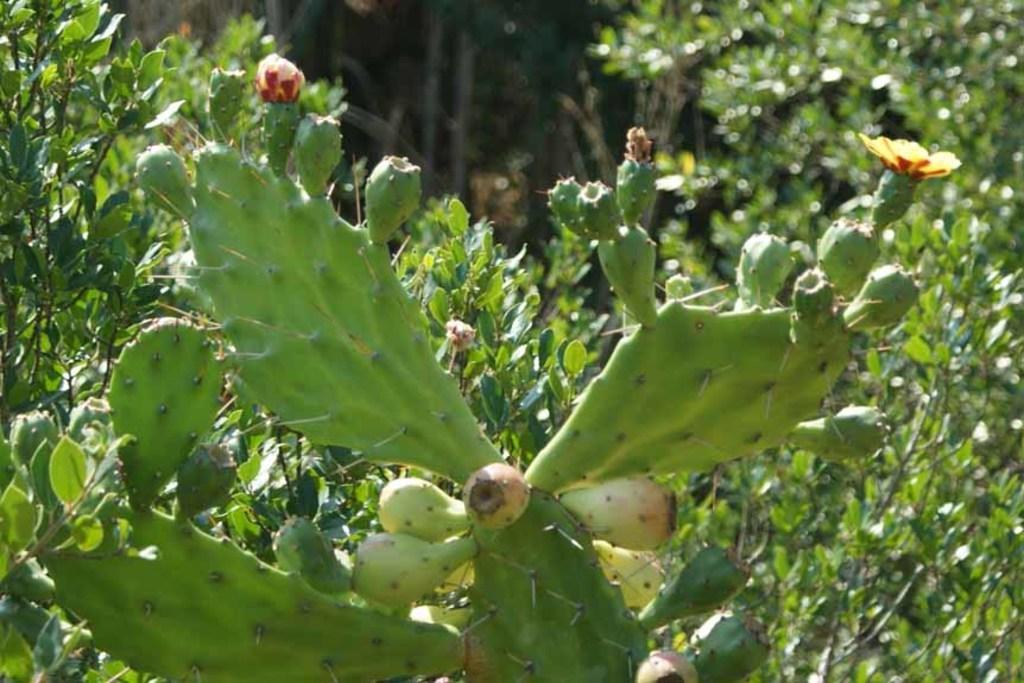Can you describe this image briefly? There is a cactus plant with flowers. In the background there are trees. 